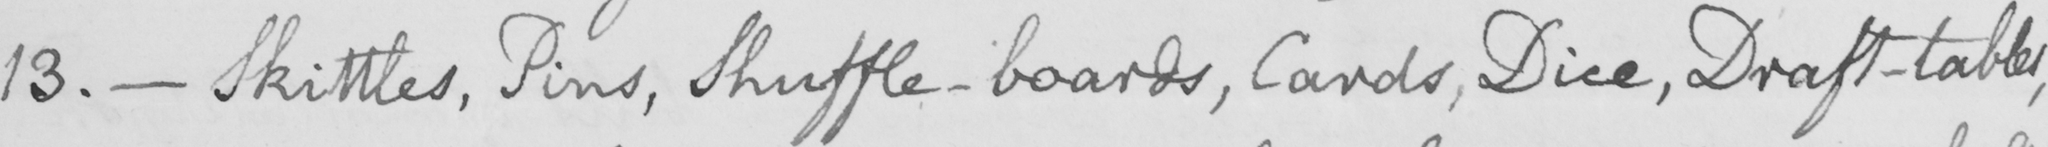Transcribe the text shown in this historical manuscript line. 13 .  _  Skittles , Pins , Shuffle-boards , Cards , Dice , Draft-tables , 